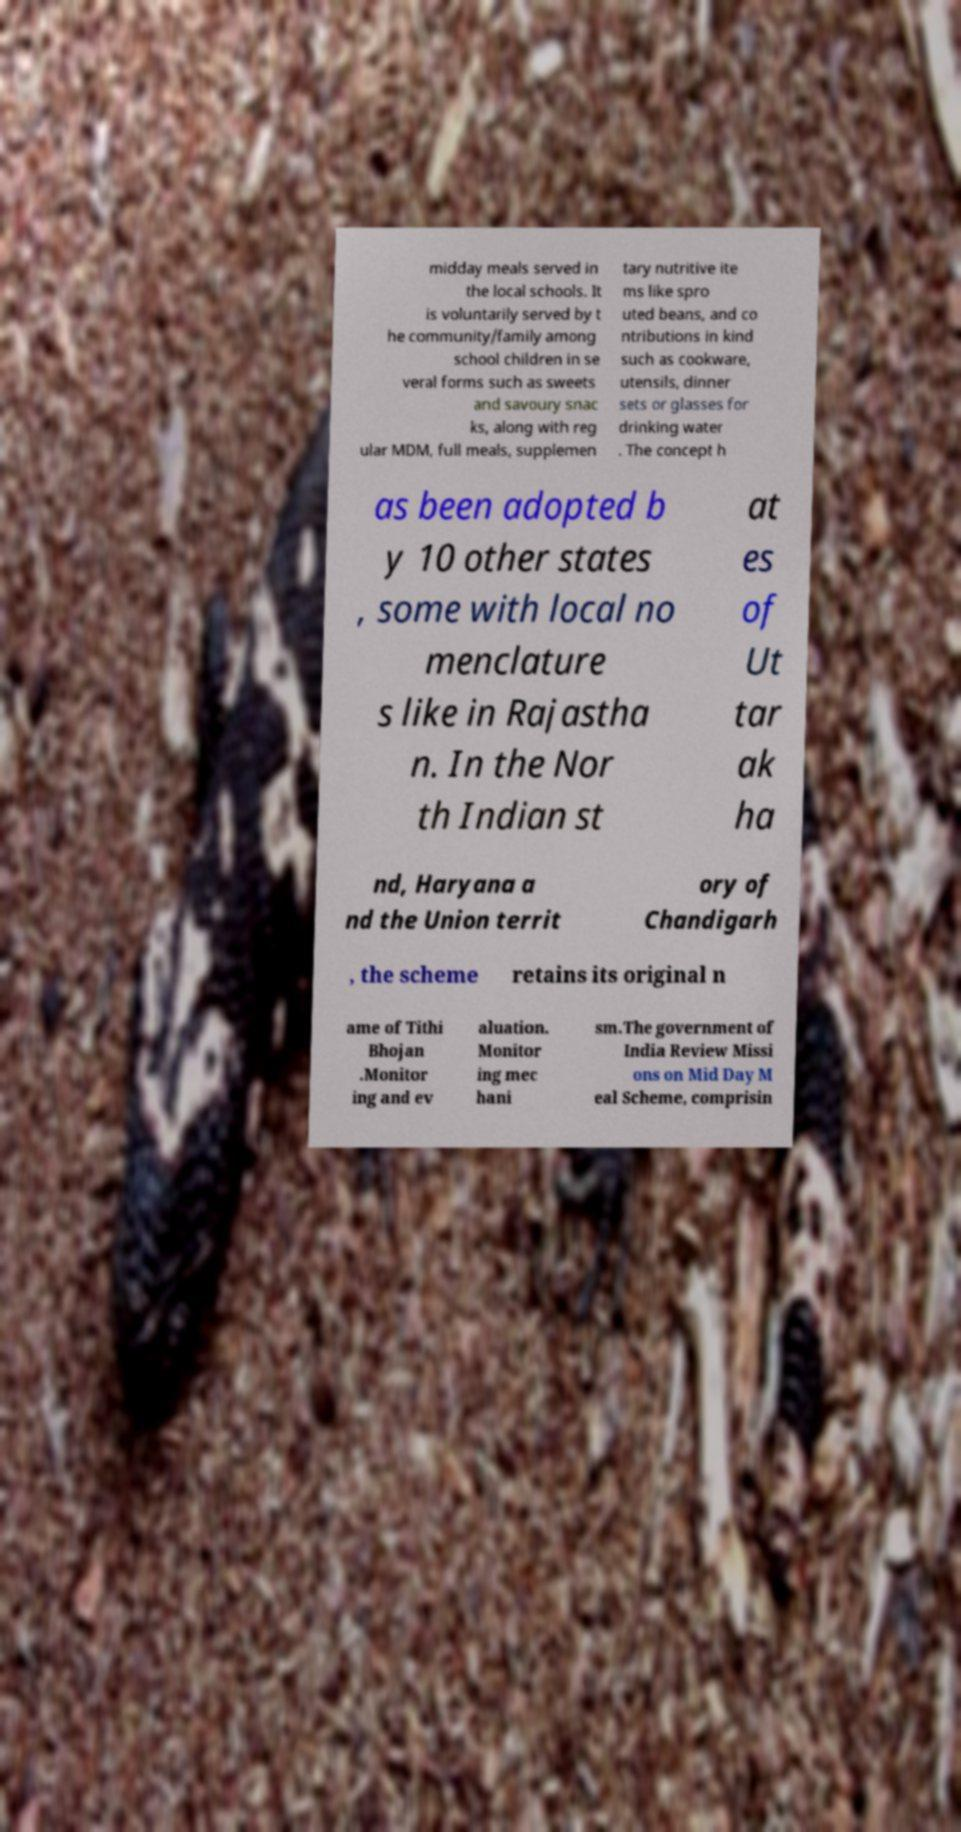For documentation purposes, I need the text within this image transcribed. Could you provide that? midday meals served in the local schools. It is voluntarily served by t he community/family among school children in se veral forms such as sweets and savoury snac ks, along with reg ular MDM, full meals, supplemen tary nutritive ite ms like spro uted beans, and co ntributions in kind such as cookware, utensils, dinner sets or glasses for drinking water . The concept h as been adopted b y 10 other states , some with local no menclature s like in Rajastha n. In the Nor th Indian st at es of Ut tar ak ha nd, Haryana a nd the Union territ ory of Chandigarh , the scheme retains its original n ame of Tithi Bhojan .Monitor ing and ev aluation. Monitor ing mec hani sm.The government of India Review Missi ons on Mid Day M eal Scheme, comprisin 